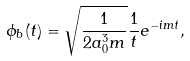Convert formula to latex. <formula><loc_0><loc_0><loc_500><loc_500>\phi _ { b } ( t ) = \sqrt { \frac { 1 } { 2 a _ { 0 } ^ { 3 } m } } \frac { 1 } { t } e ^ { - i m t } ,</formula> 